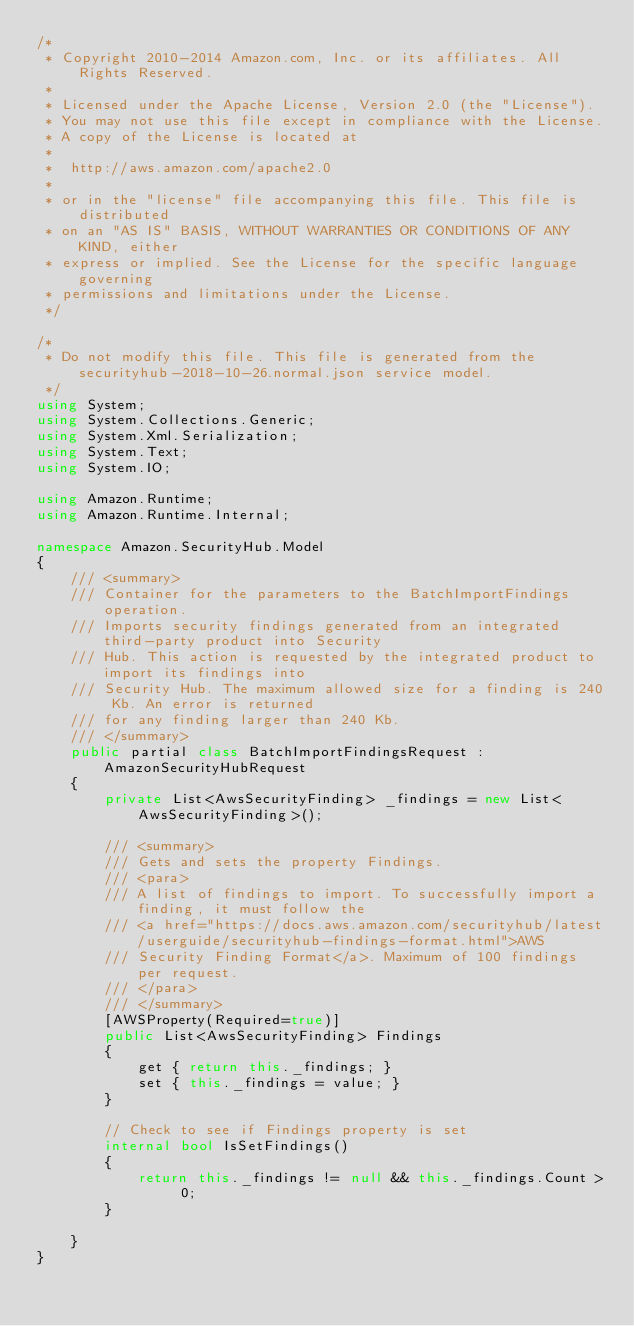<code> <loc_0><loc_0><loc_500><loc_500><_C#_>/*
 * Copyright 2010-2014 Amazon.com, Inc. or its affiliates. All Rights Reserved.
 * 
 * Licensed under the Apache License, Version 2.0 (the "License").
 * You may not use this file except in compliance with the License.
 * A copy of the License is located at
 * 
 *  http://aws.amazon.com/apache2.0
 * 
 * or in the "license" file accompanying this file. This file is distributed
 * on an "AS IS" BASIS, WITHOUT WARRANTIES OR CONDITIONS OF ANY KIND, either
 * express or implied. See the License for the specific language governing
 * permissions and limitations under the License.
 */

/*
 * Do not modify this file. This file is generated from the securityhub-2018-10-26.normal.json service model.
 */
using System;
using System.Collections.Generic;
using System.Xml.Serialization;
using System.Text;
using System.IO;

using Amazon.Runtime;
using Amazon.Runtime.Internal;

namespace Amazon.SecurityHub.Model
{
    /// <summary>
    /// Container for the parameters to the BatchImportFindings operation.
    /// Imports security findings generated from an integrated third-party product into Security
    /// Hub. This action is requested by the integrated product to import its findings into
    /// Security Hub. The maximum allowed size for a finding is 240 Kb. An error is returned
    /// for any finding larger than 240 Kb.
    /// </summary>
    public partial class BatchImportFindingsRequest : AmazonSecurityHubRequest
    {
        private List<AwsSecurityFinding> _findings = new List<AwsSecurityFinding>();

        /// <summary>
        /// Gets and sets the property Findings. 
        /// <para>
        /// A list of findings to import. To successfully import a finding, it must follow the
        /// <a href="https://docs.aws.amazon.com/securityhub/latest/userguide/securityhub-findings-format.html">AWS
        /// Security Finding Format</a>. Maximum of 100 findings per request.
        /// </para>
        /// </summary>
        [AWSProperty(Required=true)]
        public List<AwsSecurityFinding> Findings
        {
            get { return this._findings; }
            set { this._findings = value; }
        }

        // Check to see if Findings property is set
        internal bool IsSetFindings()
        {
            return this._findings != null && this._findings.Count > 0; 
        }

    }
}</code> 